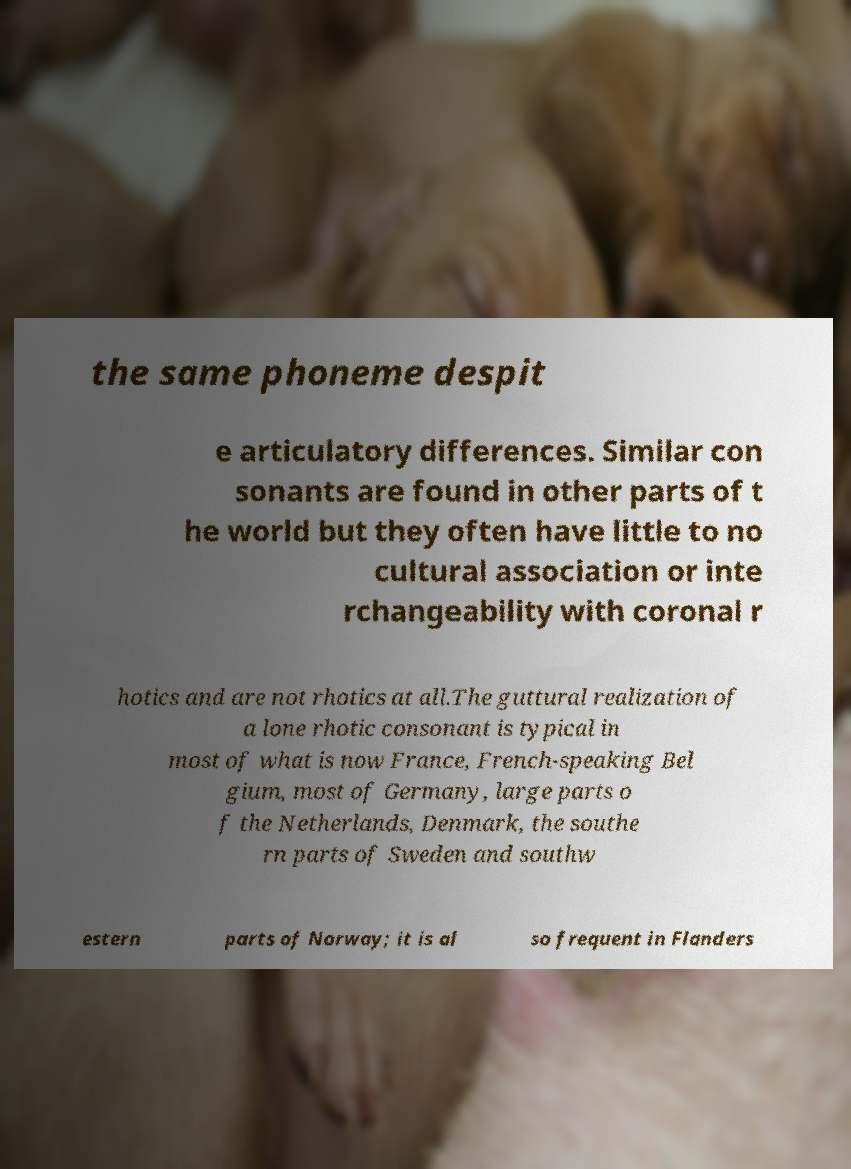Could you assist in decoding the text presented in this image and type it out clearly? the same phoneme despit e articulatory differences. Similar con sonants are found in other parts of t he world but they often have little to no cultural association or inte rchangeability with coronal r hotics and are not rhotics at all.The guttural realization of a lone rhotic consonant is typical in most of what is now France, French-speaking Bel gium, most of Germany, large parts o f the Netherlands, Denmark, the southe rn parts of Sweden and southw estern parts of Norway; it is al so frequent in Flanders 